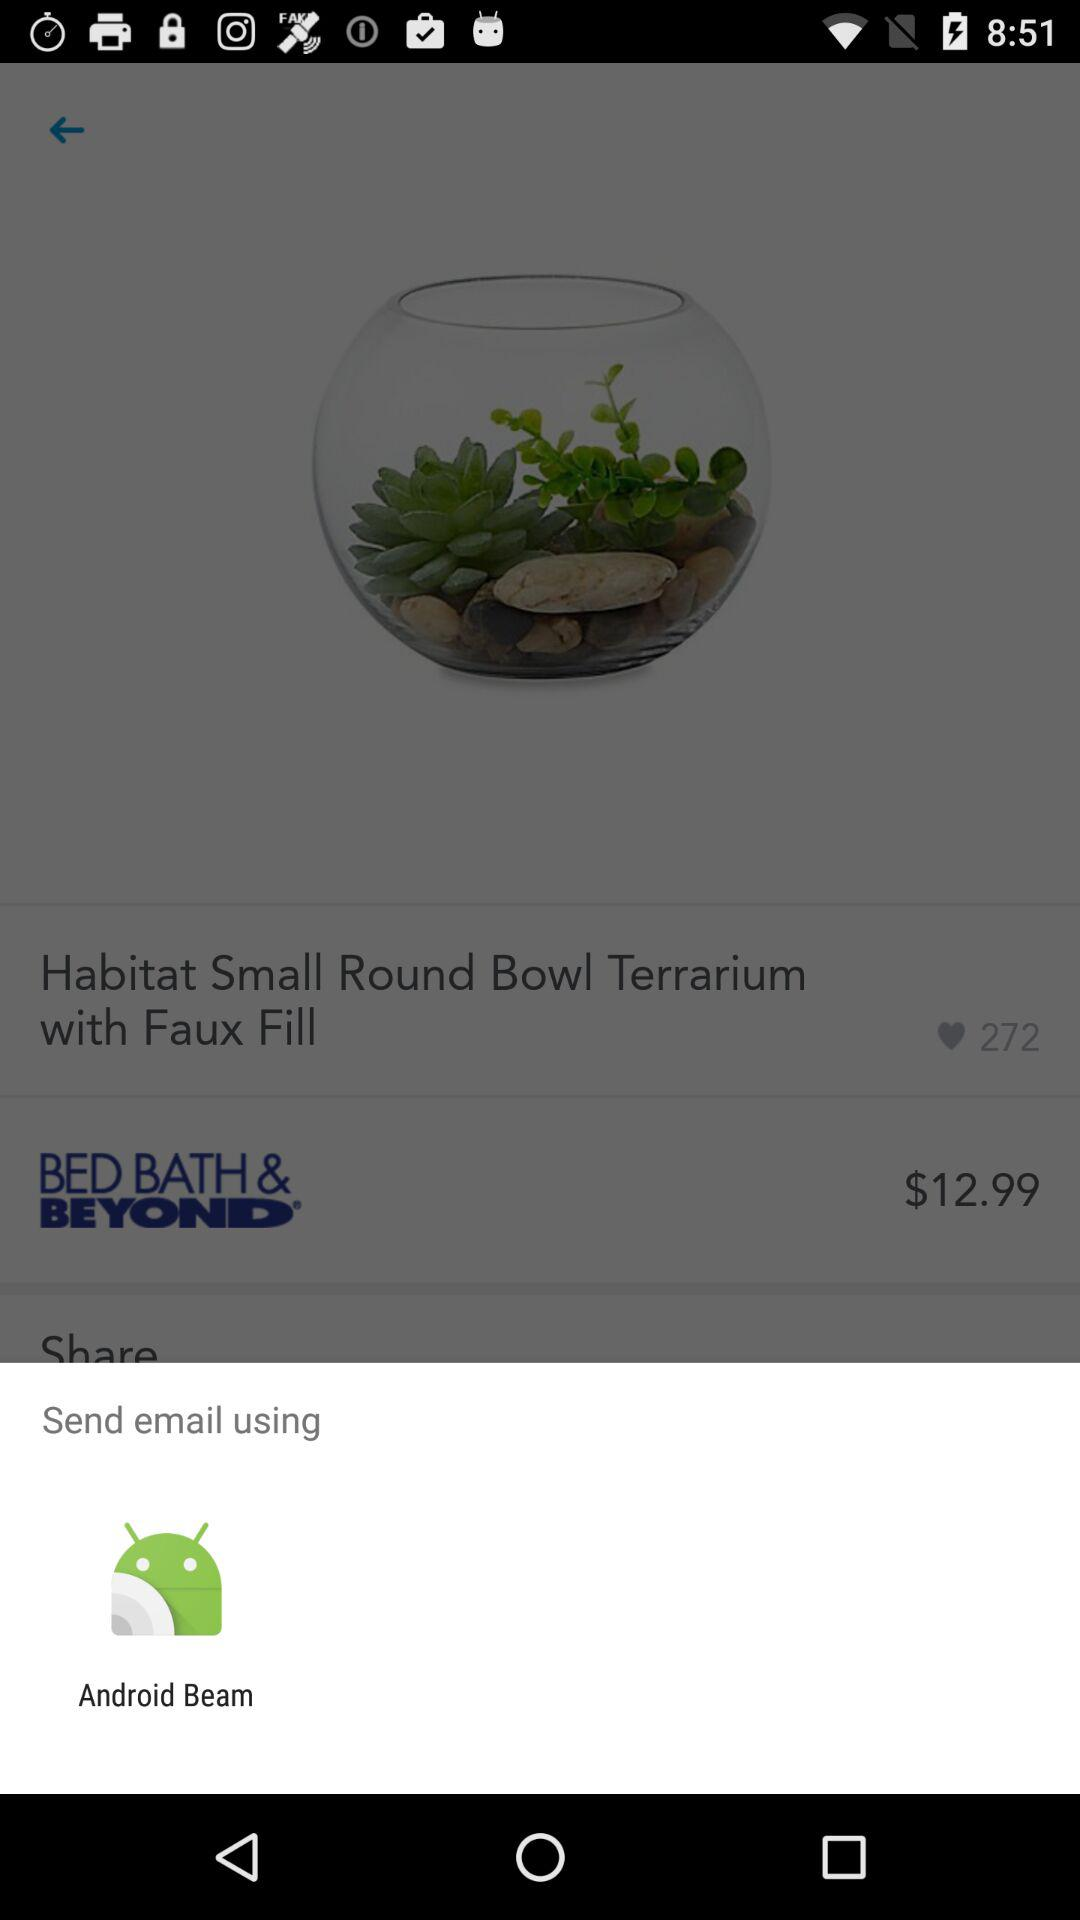What is the sum of the prices of the items in the cart?
Answer the question using a single word or phrase. $12.99 